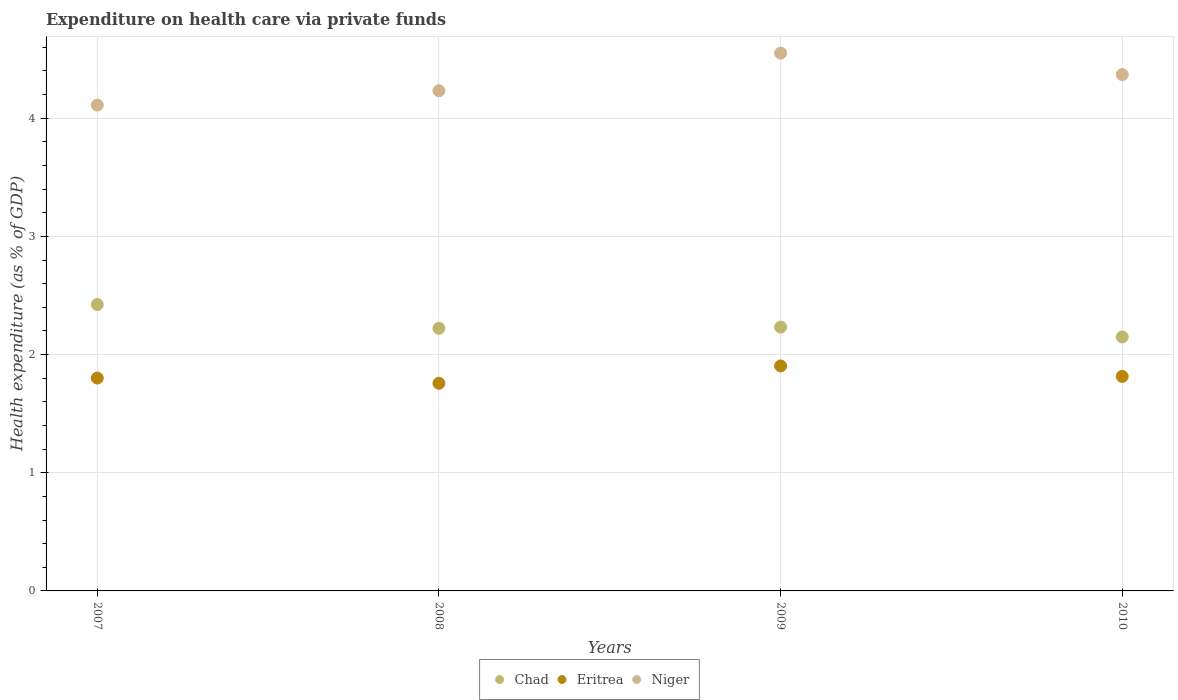What is the expenditure made on health care in Niger in 2007?
Keep it short and to the point. 4.11. Across all years, what is the maximum expenditure made on health care in Niger?
Keep it short and to the point. 4.55. Across all years, what is the minimum expenditure made on health care in Chad?
Your answer should be compact. 2.15. In which year was the expenditure made on health care in Eritrea maximum?
Your response must be concise. 2009. What is the total expenditure made on health care in Eritrea in the graph?
Give a very brief answer. 7.28. What is the difference between the expenditure made on health care in Niger in 2008 and that in 2009?
Offer a terse response. -0.32. What is the difference between the expenditure made on health care in Eritrea in 2009 and the expenditure made on health care in Niger in 2007?
Offer a terse response. -2.21. What is the average expenditure made on health care in Chad per year?
Provide a succinct answer. 2.26. In the year 2007, what is the difference between the expenditure made on health care in Chad and expenditure made on health care in Niger?
Your answer should be compact. -1.69. What is the ratio of the expenditure made on health care in Chad in 2007 to that in 2010?
Offer a terse response. 1.13. What is the difference between the highest and the second highest expenditure made on health care in Niger?
Offer a terse response. 0.18. What is the difference between the highest and the lowest expenditure made on health care in Eritrea?
Offer a very short reply. 0.15. In how many years, is the expenditure made on health care in Niger greater than the average expenditure made on health care in Niger taken over all years?
Your answer should be compact. 2. Does the expenditure made on health care in Eritrea monotonically increase over the years?
Keep it short and to the point. No. Is the expenditure made on health care in Chad strictly greater than the expenditure made on health care in Niger over the years?
Offer a very short reply. No. Is the expenditure made on health care in Eritrea strictly less than the expenditure made on health care in Chad over the years?
Your response must be concise. Yes. How many dotlines are there?
Provide a succinct answer. 3. How many years are there in the graph?
Ensure brevity in your answer.  4. Are the values on the major ticks of Y-axis written in scientific E-notation?
Give a very brief answer. No. Does the graph contain grids?
Provide a short and direct response. Yes. Where does the legend appear in the graph?
Give a very brief answer. Bottom center. How are the legend labels stacked?
Provide a short and direct response. Horizontal. What is the title of the graph?
Your response must be concise. Expenditure on health care via private funds. Does "Belarus" appear as one of the legend labels in the graph?
Your response must be concise. No. What is the label or title of the X-axis?
Offer a very short reply. Years. What is the label or title of the Y-axis?
Provide a short and direct response. Health expenditure (as % of GDP). What is the Health expenditure (as % of GDP) in Chad in 2007?
Your response must be concise. 2.42. What is the Health expenditure (as % of GDP) of Eritrea in 2007?
Your response must be concise. 1.8. What is the Health expenditure (as % of GDP) of Niger in 2007?
Provide a short and direct response. 4.11. What is the Health expenditure (as % of GDP) in Chad in 2008?
Your response must be concise. 2.22. What is the Health expenditure (as % of GDP) of Eritrea in 2008?
Your answer should be very brief. 1.76. What is the Health expenditure (as % of GDP) in Niger in 2008?
Offer a terse response. 4.23. What is the Health expenditure (as % of GDP) of Chad in 2009?
Ensure brevity in your answer.  2.23. What is the Health expenditure (as % of GDP) of Eritrea in 2009?
Provide a succinct answer. 1.9. What is the Health expenditure (as % of GDP) of Niger in 2009?
Offer a terse response. 4.55. What is the Health expenditure (as % of GDP) in Chad in 2010?
Offer a very short reply. 2.15. What is the Health expenditure (as % of GDP) in Eritrea in 2010?
Your response must be concise. 1.82. What is the Health expenditure (as % of GDP) of Niger in 2010?
Offer a terse response. 4.37. Across all years, what is the maximum Health expenditure (as % of GDP) of Chad?
Your answer should be compact. 2.42. Across all years, what is the maximum Health expenditure (as % of GDP) of Eritrea?
Ensure brevity in your answer.  1.9. Across all years, what is the maximum Health expenditure (as % of GDP) of Niger?
Your answer should be compact. 4.55. Across all years, what is the minimum Health expenditure (as % of GDP) of Chad?
Offer a very short reply. 2.15. Across all years, what is the minimum Health expenditure (as % of GDP) in Eritrea?
Your answer should be very brief. 1.76. Across all years, what is the minimum Health expenditure (as % of GDP) of Niger?
Your response must be concise. 4.11. What is the total Health expenditure (as % of GDP) in Chad in the graph?
Give a very brief answer. 9.03. What is the total Health expenditure (as % of GDP) of Eritrea in the graph?
Provide a short and direct response. 7.28. What is the total Health expenditure (as % of GDP) in Niger in the graph?
Offer a terse response. 17.26. What is the difference between the Health expenditure (as % of GDP) in Chad in 2007 and that in 2008?
Provide a short and direct response. 0.2. What is the difference between the Health expenditure (as % of GDP) in Eritrea in 2007 and that in 2008?
Ensure brevity in your answer.  0.04. What is the difference between the Health expenditure (as % of GDP) of Niger in 2007 and that in 2008?
Give a very brief answer. -0.12. What is the difference between the Health expenditure (as % of GDP) in Chad in 2007 and that in 2009?
Give a very brief answer. 0.19. What is the difference between the Health expenditure (as % of GDP) of Eritrea in 2007 and that in 2009?
Provide a succinct answer. -0.1. What is the difference between the Health expenditure (as % of GDP) of Niger in 2007 and that in 2009?
Your response must be concise. -0.44. What is the difference between the Health expenditure (as % of GDP) of Chad in 2007 and that in 2010?
Your answer should be very brief. 0.27. What is the difference between the Health expenditure (as % of GDP) of Eritrea in 2007 and that in 2010?
Give a very brief answer. -0.01. What is the difference between the Health expenditure (as % of GDP) in Niger in 2007 and that in 2010?
Your answer should be compact. -0.26. What is the difference between the Health expenditure (as % of GDP) of Chad in 2008 and that in 2009?
Provide a short and direct response. -0.01. What is the difference between the Health expenditure (as % of GDP) in Eritrea in 2008 and that in 2009?
Offer a terse response. -0.15. What is the difference between the Health expenditure (as % of GDP) of Niger in 2008 and that in 2009?
Offer a very short reply. -0.32. What is the difference between the Health expenditure (as % of GDP) in Chad in 2008 and that in 2010?
Offer a terse response. 0.07. What is the difference between the Health expenditure (as % of GDP) of Eritrea in 2008 and that in 2010?
Give a very brief answer. -0.06. What is the difference between the Health expenditure (as % of GDP) of Niger in 2008 and that in 2010?
Provide a succinct answer. -0.14. What is the difference between the Health expenditure (as % of GDP) in Chad in 2009 and that in 2010?
Your answer should be very brief. 0.08. What is the difference between the Health expenditure (as % of GDP) in Eritrea in 2009 and that in 2010?
Provide a succinct answer. 0.09. What is the difference between the Health expenditure (as % of GDP) of Niger in 2009 and that in 2010?
Ensure brevity in your answer.  0.18. What is the difference between the Health expenditure (as % of GDP) of Chad in 2007 and the Health expenditure (as % of GDP) of Eritrea in 2008?
Offer a terse response. 0.67. What is the difference between the Health expenditure (as % of GDP) of Chad in 2007 and the Health expenditure (as % of GDP) of Niger in 2008?
Ensure brevity in your answer.  -1.81. What is the difference between the Health expenditure (as % of GDP) in Eritrea in 2007 and the Health expenditure (as % of GDP) in Niger in 2008?
Ensure brevity in your answer.  -2.43. What is the difference between the Health expenditure (as % of GDP) in Chad in 2007 and the Health expenditure (as % of GDP) in Eritrea in 2009?
Make the answer very short. 0.52. What is the difference between the Health expenditure (as % of GDP) of Chad in 2007 and the Health expenditure (as % of GDP) of Niger in 2009?
Make the answer very short. -2.13. What is the difference between the Health expenditure (as % of GDP) of Eritrea in 2007 and the Health expenditure (as % of GDP) of Niger in 2009?
Provide a short and direct response. -2.75. What is the difference between the Health expenditure (as % of GDP) in Chad in 2007 and the Health expenditure (as % of GDP) in Eritrea in 2010?
Your answer should be very brief. 0.61. What is the difference between the Health expenditure (as % of GDP) in Chad in 2007 and the Health expenditure (as % of GDP) in Niger in 2010?
Your answer should be compact. -1.95. What is the difference between the Health expenditure (as % of GDP) of Eritrea in 2007 and the Health expenditure (as % of GDP) of Niger in 2010?
Make the answer very short. -2.57. What is the difference between the Health expenditure (as % of GDP) in Chad in 2008 and the Health expenditure (as % of GDP) in Eritrea in 2009?
Keep it short and to the point. 0.32. What is the difference between the Health expenditure (as % of GDP) in Chad in 2008 and the Health expenditure (as % of GDP) in Niger in 2009?
Your response must be concise. -2.33. What is the difference between the Health expenditure (as % of GDP) of Eritrea in 2008 and the Health expenditure (as % of GDP) of Niger in 2009?
Your answer should be compact. -2.79. What is the difference between the Health expenditure (as % of GDP) in Chad in 2008 and the Health expenditure (as % of GDP) in Eritrea in 2010?
Your response must be concise. 0.41. What is the difference between the Health expenditure (as % of GDP) in Chad in 2008 and the Health expenditure (as % of GDP) in Niger in 2010?
Keep it short and to the point. -2.15. What is the difference between the Health expenditure (as % of GDP) of Eritrea in 2008 and the Health expenditure (as % of GDP) of Niger in 2010?
Your answer should be compact. -2.61. What is the difference between the Health expenditure (as % of GDP) of Chad in 2009 and the Health expenditure (as % of GDP) of Eritrea in 2010?
Ensure brevity in your answer.  0.42. What is the difference between the Health expenditure (as % of GDP) of Chad in 2009 and the Health expenditure (as % of GDP) of Niger in 2010?
Your answer should be very brief. -2.14. What is the difference between the Health expenditure (as % of GDP) of Eritrea in 2009 and the Health expenditure (as % of GDP) of Niger in 2010?
Provide a short and direct response. -2.47. What is the average Health expenditure (as % of GDP) of Chad per year?
Offer a terse response. 2.26. What is the average Health expenditure (as % of GDP) in Eritrea per year?
Provide a succinct answer. 1.82. What is the average Health expenditure (as % of GDP) of Niger per year?
Provide a succinct answer. 4.32. In the year 2007, what is the difference between the Health expenditure (as % of GDP) in Chad and Health expenditure (as % of GDP) in Eritrea?
Give a very brief answer. 0.62. In the year 2007, what is the difference between the Health expenditure (as % of GDP) in Chad and Health expenditure (as % of GDP) in Niger?
Your answer should be very brief. -1.69. In the year 2007, what is the difference between the Health expenditure (as % of GDP) in Eritrea and Health expenditure (as % of GDP) in Niger?
Provide a short and direct response. -2.31. In the year 2008, what is the difference between the Health expenditure (as % of GDP) in Chad and Health expenditure (as % of GDP) in Eritrea?
Ensure brevity in your answer.  0.47. In the year 2008, what is the difference between the Health expenditure (as % of GDP) of Chad and Health expenditure (as % of GDP) of Niger?
Ensure brevity in your answer.  -2.01. In the year 2008, what is the difference between the Health expenditure (as % of GDP) in Eritrea and Health expenditure (as % of GDP) in Niger?
Offer a very short reply. -2.48. In the year 2009, what is the difference between the Health expenditure (as % of GDP) of Chad and Health expenditure (as % of GDP) of Eritrea?
Your answer should be compact. 0.33. In the year 2009, what is the difference between the Health expenditure (as % of GDP) of Chad and Health expenditure (as % of GDP) of Niger?
Your answer should be very brief. -2.32. In the year 2009, what is the difference between the Health expenditure (as % of GDP) of Eritrea and Health expenditure (as % of GDP) of Niger?
Provide a succinct answer. -2.65. In the year 2010, what is the difference between the Health expenditure (as % of GDP) in Chad and Health expenditure (as % of GDP) in Eritrea?
Offer a very short reply. 0.33. In the year 2010, what is the difference between the Health expenditure (as % of GDP) in Chad and Health expenditure (as % of GDP) in Niger?
Offer a terse response. -2.22. In the year 2010, what is the difference between the Health expenditure (as % of GDP) of Eritrea and Health expenditure (as % of GDP) of Niger?
Your answer should be compact. -2.55. What is the ratio of the Health expenditure (as % of GDP) in Chad in 2007 to that in 2008?
Your answer should be very brief. 1.09. What is the ratio of the Health expenditure (as % of GDP) in Eritrea in 2007 to that in 2008?
Offer a terse response. 1.03. What is the ratio of the Health expenditure (as % of GDP) in Niger in 2007 to that in 2008?
Offer a very short reply. 0.97. What is the ratio of the Health expenditure (as % of GDP) in Chad in 2007 to that in 2009?
Keep it short and to the point. 1.09. What is the ratio of the Health expenditure (as % of GDP) of Eritrea in 2007 to that in 2009?
Offer a very short reply. 0.95. What is the ratio of the Health expenditure (as % of GDP) in Niger in 2007 to that in 2009?
Give a very brief answer. 0.9. What is the ratio of the Health expenditure (as % of GDP) of Chad in 2007 to that in 2010?
Offer a very short reply. 1.13. What is the ratio of the Health expenditure (as % of GDP) in Niger in 2007 to that in 2010?
Offer a very short reply. 0.94. What is the ratio of the Health expenditure (as % of GDP) in Chad in 2008 to that in 2009?
Your answer should be compact. 1. What is the ratio of the Health expenditure (as % of GDP) of Eritrea in 2008 to that in 2009?
Make the answer very short. 0.92. What is the ratio of the Health expenditure (as % of GDP) of Chad in 2008 to that in 2010?
Your answer should be compact. 1.03. What is the ratio of the Health expenditure (as % of GDP) of Eritrea in 2008 to that in 2010?
Ensure brevity in your answer.  0.97. What is the ratio of the Health expenditure (as % of GDP) of Niger in 2008 to that in 2010?
Your response must be concise. 0.97. What is the ratio of the Health expenditure (as % of GDP) of Chad in 2009 to that in 2010?
Your answer should be compact. 1.04. What is the ratio of the Health expenditure (as % of GDP) of Eritrea in 2009 to that in 2010?
Make the answer very short. 1.05. What is the ratio of the Health expenditure (as % of GDP) in Niger in 2009 to that in 2010?
Keep it short and to the point. 1.04. What is the difference between the highest and the second highest Health expenditure (as % of GDP) in Chad?
Offer a very short reply. 0.19. What is the difference between the highest and the second highest Health expenditure (as % of GDP) in Eritrea?
Give a very brief answer. 0.09. What is the difference between the highest and the second highest Health expenditure (as % of GDP) in Niger?
Provide a succinct answer. 0.18. What is the difference between the highest and the lowest Health expenditure (as % of GDP) of Chad?
Your answer should be compact. 0.27. What is the difference between the highest and the lowest Health expenditure (as % of GDP) of Eritrea?
Make the answer very short. 0.15. What is the difference between the highest and the lowest Health expenditure (as % of GDP) in Niger?
Your response must be concise. 0.44. 